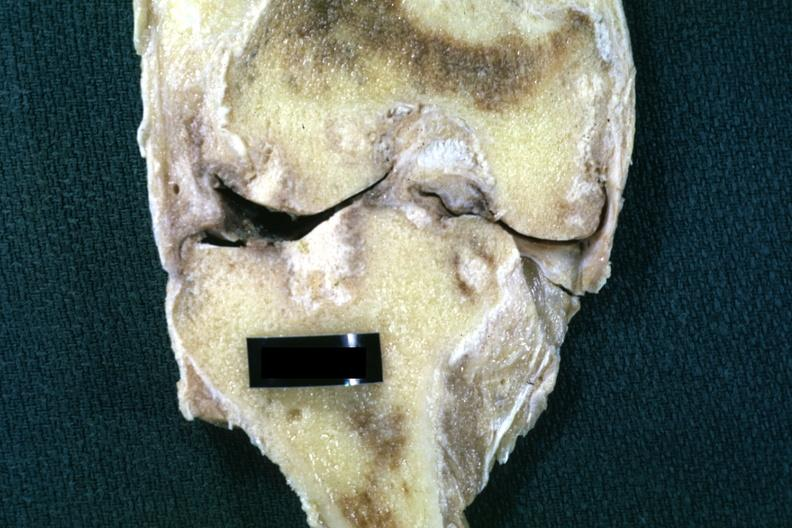what is present?
Answer the question using a single word or phrase. Joints 